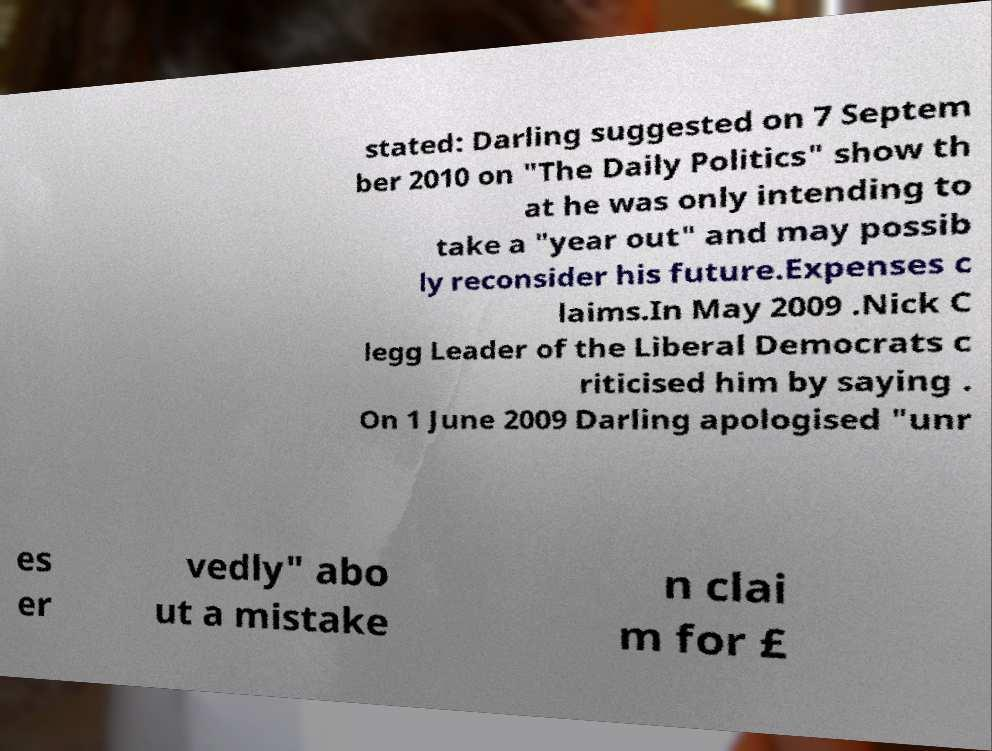Could you assist in decoding the text presented in this image and type it out clearly? stated: Darling suggested on 7 Septem ber 2010 on "The Daily Politics" show th at he was only intending to take a "year out" and may possib ly reconsider his future.Expenses c laims.In May 2009 .Nick C legg Leader of the Liberal Democrats c riticised him by saying . On 1 June 2009 Darling apologised "unr es er vedly" abo ut a mistake n clai m for £ 